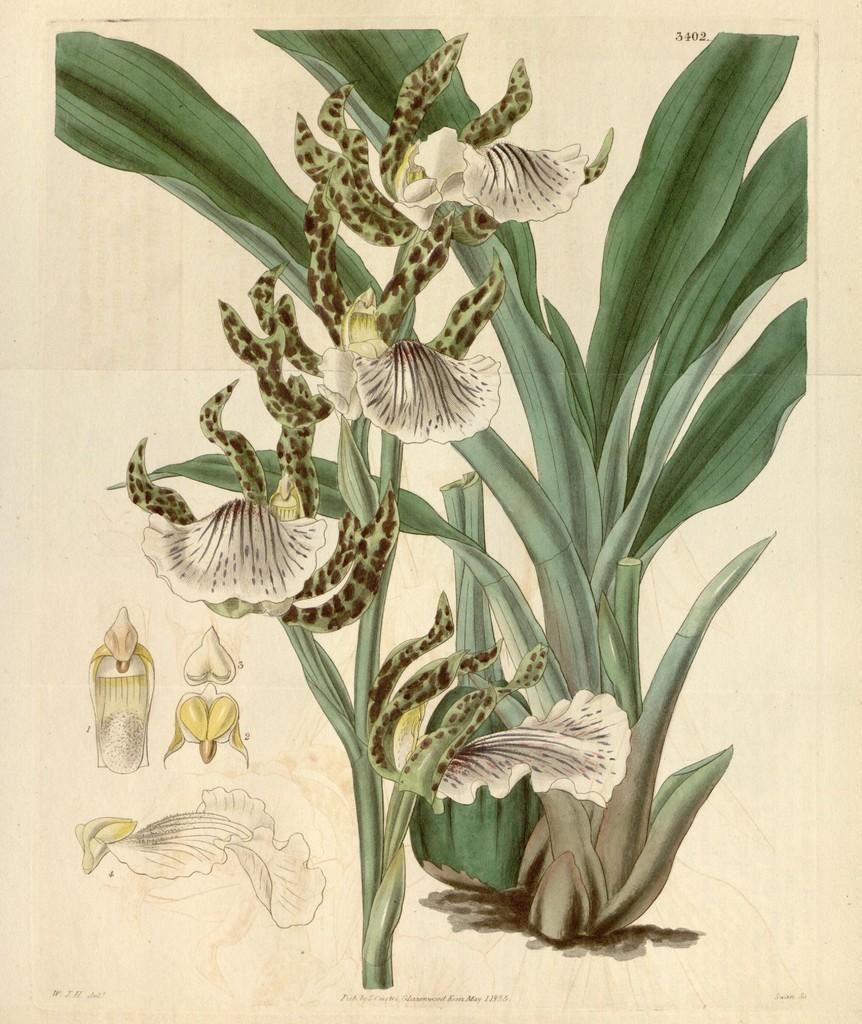What is present in the image? There is a plant in the image. What can be observed about the plant? The plant has flowers. What type of quilt is being used to cover the tank in the image? There is no quilt or tank present in the image; it only features a plant with flowers. 